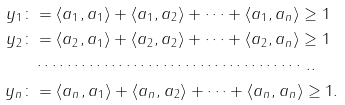Convert formula to latex. <formula><loc_0><loc_0><loc_500><loc_500>y _ { 1 } \colon & = \langle a _ { 1 } , a _ { 1 } \rangle + \langle a _ { 1 } , a _ { 2 } \rangle + \dots + \langle a _ { 1 } , a _ { n } \rangle \geq 1 \\ y _ { 2 } \colon & = \langle a _ { 2 } , a _ { 1 } \rangle + \langle a _ { 2 } , a _ { 2 } \rangle + \dots + \langle a _ { 2 } , a _ { n } \rangle \geq 1 \\ & \cdots \cdots \cdots \cdots \cdots \cdots \cdots \cdots \cdots \cdots \cdots \cdots . . \\ y _ { n } \colon & = \langle a _ { n } , a _ { 1 } \rangle + \langle a _ { n } , a _ { 2 } \rangle + \dots + \langle a _ { n } , a _ { n } \rangle \geq 1 .</formula> 